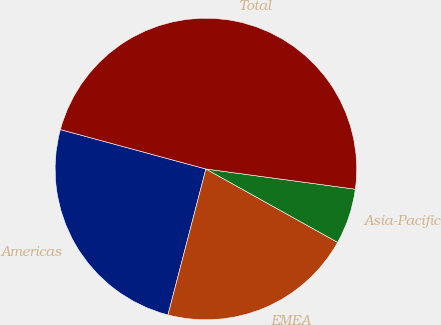Convert chart. <chart><loc_0><loc_0><loc_500><loc_500><pie_chart><fcel>Americas<fcel>EMEA<fcel>Asia-Pacific<fcel>Total<nl><fcel>25.16%<fcel>20.96%<fcel>5.95%<fcel>47.93%<nl></chart> 